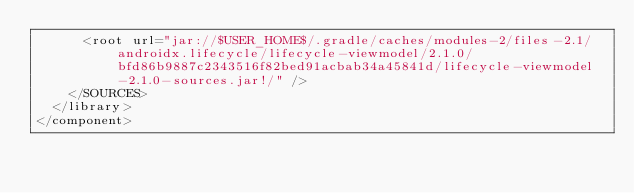<code> <loc_0><loc_0><loc_500><loc_500><_XML_>      <root url="jar://$USER_HOME$/.gradle/caches/modules-2/files-2.1/androidx.lifecycle/lifecycle-viewmodel/2.1.0/bfd86b9887c2343516f82bed91acbab34a45841d/lifecycle-viewmodel-2.1.0-sources.jar!/" />
    </SOURCES>
  </library>
</component></code> 